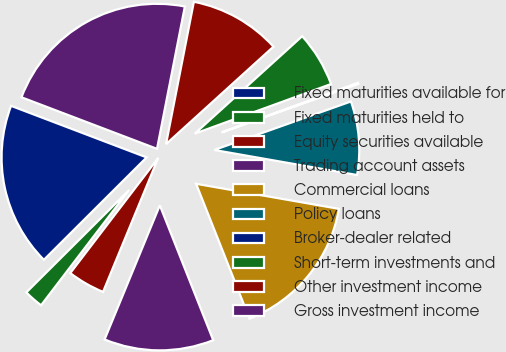<chart> <loc_0><loc_0><loc_500><loc_500><pie_chart><fcel>Fixed maturities available for<fcel>Fixed maturities held to<fcel>Equity securities available<fcel>Trading account assets<fcel>Commercial loans<fcel>Policy loans<fcel>Broker-dealer related<fcel>Short-term investments and<fcel>Other investment income<fcel>Gross investment income<nl><fcel>18.26%<fcel>2.15%<fcel>4.16%<fcel>12.22%<fcel>16.24%<fcel>8.19%<fcel>0.13%<fcel>6.17%<fcel>10.2%<fcel>22.29%<nl></chart> 